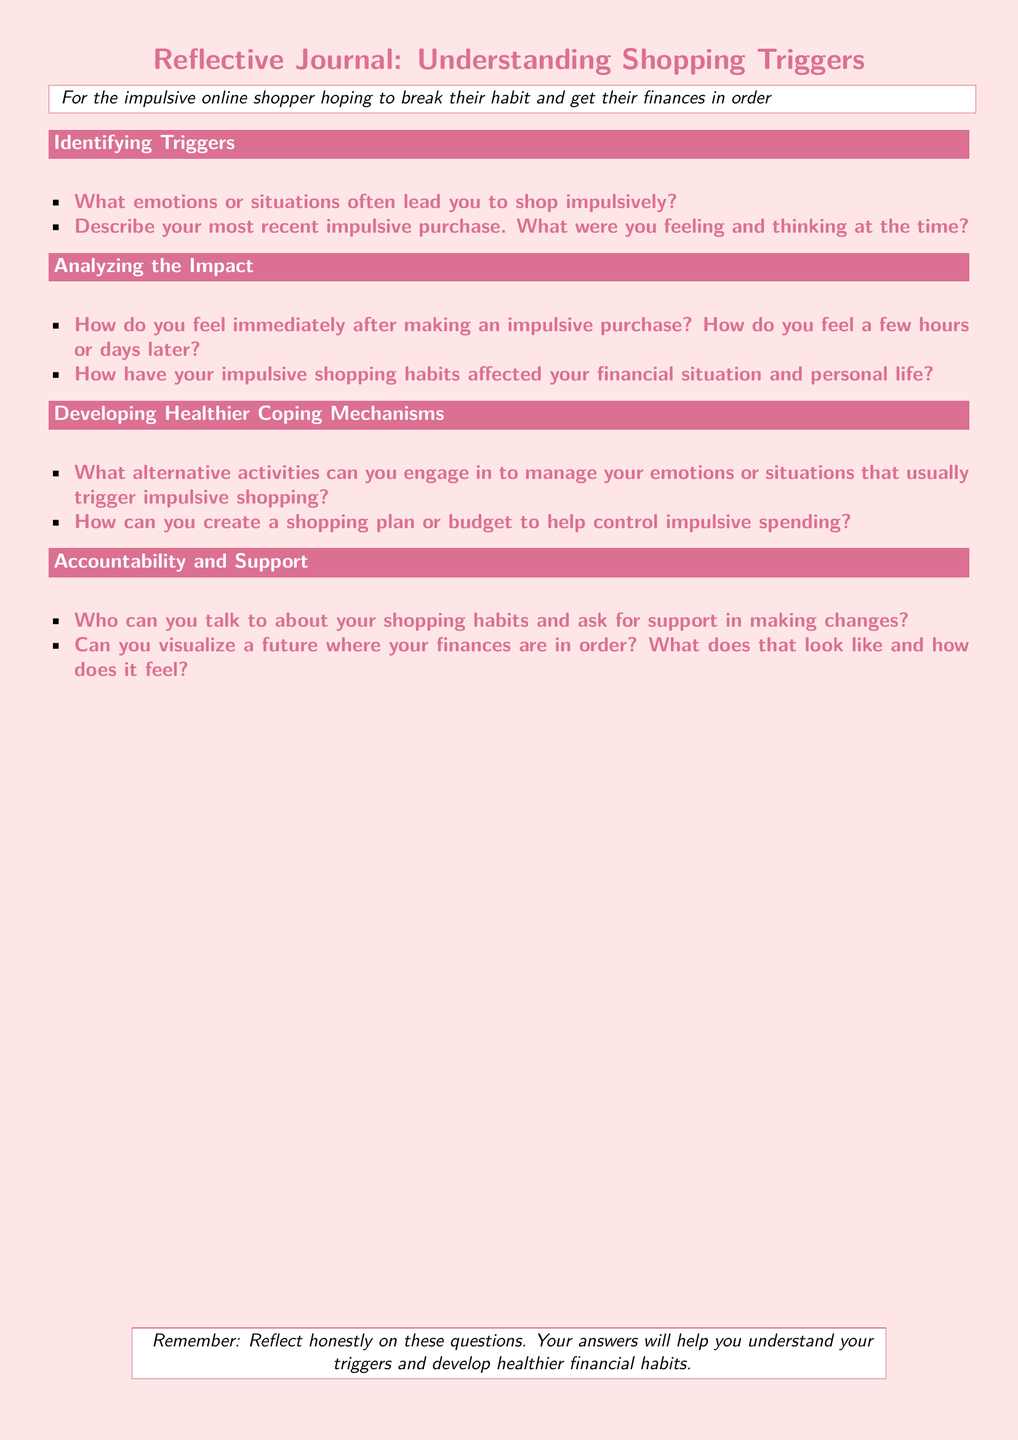What is the title of the document? The title of the document is presented prominently as part of the header, indicating the focus of the journal.
Answer: Reflective Journal: Understanding Shopping Triggers What is the color used for headings in the document? The document uses dark pink for headings to highlight different sections.
Answer: dark pink Identify one emotion that may trigger impulsive shopping. The document prompts the reader to reflect on emotions linked to shopping impulses, focusing on specific feelings.
Answer: emotions What is one suggested form of support mentioned in the document? The document encourages discussing shopping habits with someone for accountability and support.
Answer: support What should the reader visualize according to the document? The document suggests a visualization exercise regarding the reader's future financial situation.
Answer: future finances How many sections are there in the document? The document is structured into several main sections, each addressing different aspects of shopping triggers and coping mechanisms.
Answer: four 